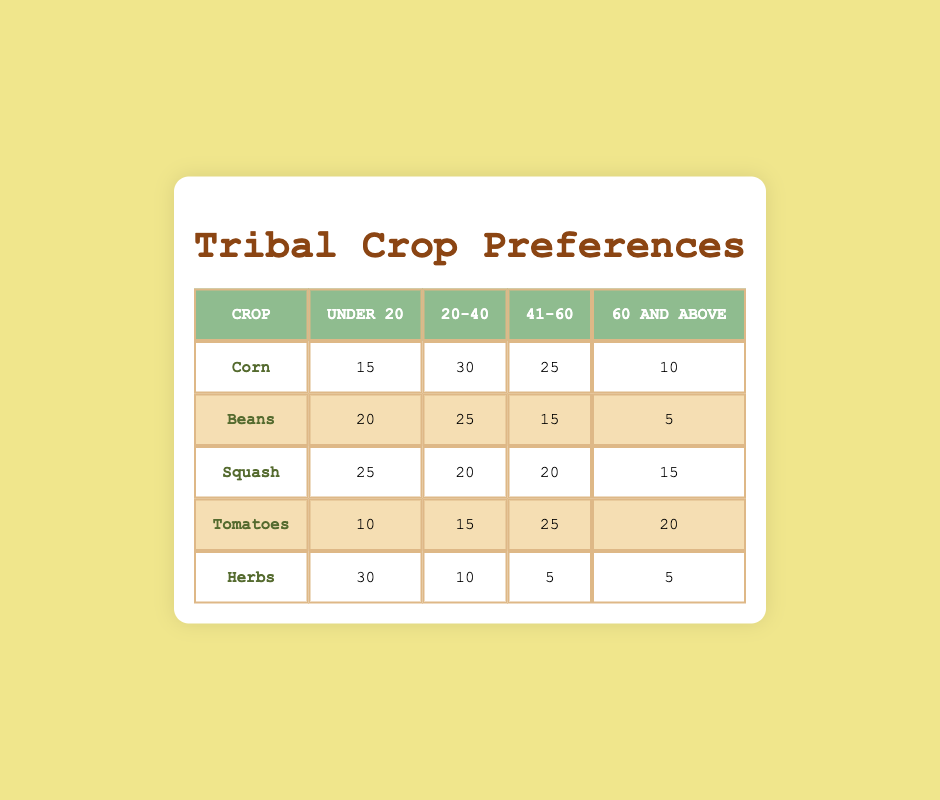What crop has the highest preference among the age group "Under 20"? In the "Under 20" age group, looking at the values in the table, "Herbs" has 30, which is higher than any other crop at that age. Corn has 15, Beans has 20, Squash has 25, and Tomatoes has 10. Thus, the answer is 30 for Herbs.
Answer: Herbs How many people in the age group "60 and above" prefer Squash? The value in the "60 and above" column for Squash is 15. There are no calculations needed, just a direct reading from the table.
Answer: 15 Which crop is least preferred by individuals aged 41 to 60? For the age group 41 to 60, the preferences are as follows: Corn (25), Beans (15), Squash (20), Tomatoes (25), and Herbs (5). The lowest value here is for Herbs with 5.
Answer: Herbs What is the combined preference for Corn and Beans by those aged 20 to 40? Adding the values for Corn and Beans in the 20 to 40 age group: Corn (30) + Beans (25) = 55. The combined preference is simply the sum of these two values.
Answer: 55 Is it true that more than 50% of individuals aged 20-40 prefer either Tomatoes or Squash? Looking at the values for Tomatoes (15) and Squash (20), together they add up to 35. The age group total is 100 for the four crops (Corn, Beans, Squash, and Tomatoes). Therefore, 35 out of 100 is not more than 50%. Thus, the statement is false.
Answer: No What crop is preferred the least by individuals aged under 20? In the "Under 20" age group, the preferences are: Corn (15), Beans (20), Squash (25), Tomatoes (10), and Herbs (30). The least preferred value is for Tomatoes with 10.
Answer: Tomatoes Calculate the average preference for all crops among individuals aged 41 to 60. For age group 41 to 60, the preference values are: Corn (25), Beans (15), Squash (20), Tomatoes (25), and Herbs (5). The sum of these values is 25 + 15 + 20 + 25 + 5 = 90. There are 5 crops, thus the average is 90 / 5 = 18.
Answer: 18 How many people prefer Corn in total across all age groups? The values for Corn are: Under 20 (15), 20 to 40 (30), 41 to 60 (25), and 60 and above (10). Summing these gives us 15 + 30 + 25 + 10 = 80. Thus, the total preference for Corn is 80.
Answer: 80 Which age group shows the highest preference for Herbs? Reviewing the preferences for Herbs by age group: Under 20 (30), 20 to 40 (10), 41 to 60 (5), and 60 and above (5). The highest value is for the Under 20 age group at 30.
Answer: Under 20 